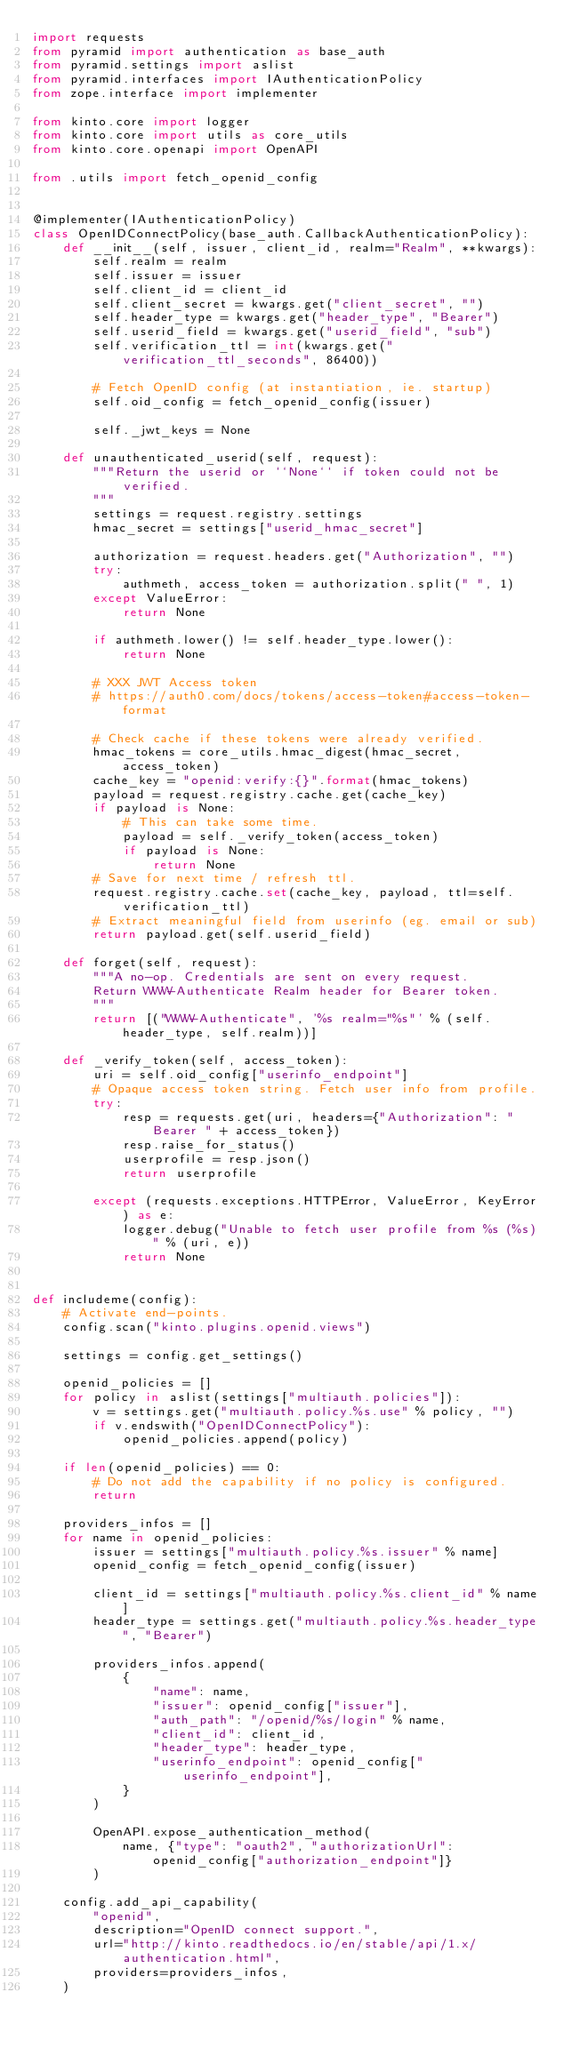Convert code to text. <code><loc_0><loc_0><loc_500><loc_500><_Python_>import requests
from pyramid import authentication as base_auth
from pyramid.settings import aslist
from pyramid.interfaces import IAuthenticationPolicy
from zope.interface import implementer

from kinto.core import logger
from kinto.core import utils as core_utils
from kinto.core.openapi import OpenAPI

from .utils import fetch_openid_config


@implementer(IAuthenticationPolicy)
class OpenIDConnectPolicy(base_auth.CallbackAuthenticationPolicy):
    def __init__(self, issuer, client_id, realm="Realm", **kwargs):
        self.realm = realm
        self.issuer = issuer
        self.client_id = client_id
        self.client_secret = kwargs.get("client_secret", "")
        self.header_type = kwargs.get("header_type", "Bearer")
        self.userid_field = kwargs.get("userid_field", "sub")
        self.verification_ttl = int(kwargs.get("verification_ttl_seconds", 86400))

        # Fetch OpenID config (at instantiation, ie. startup)
        self.oid_config = fetch_openid_config(issuer)

        self._jwt_keys = None

    def unauthenticated_userid(self, request):
        """Return the userid or ``None`` if token could not be verified.
        """
        settings = request.registry.settings
        hmac_secret = settings["userid_hmac_secret"]

        authorization = request.headers.get("Authorization", "")
        try:
            authmeth, access_token = authorization.split(" ", 1)
        except ValueError:
            return None

        if authmeth.lower() != self.header_type.lower():
            return None

        # XXX JWT Access token
        # https://auth0.com/docs/tokens/access-token#access-token-format

        # Check cache if these tokens were already verified.
        hmac_tokens = core_utils.hmac_digest(hmac_secret, access_token)
        cache_key = "openid:verify:{}".format(hmac_tokens)
        payload = request.registry.cache.get(cache_key)
        if payload is None:
            # This can take some time.
            payload = self._verify_token(access_token)
            if payload is None:
                return None
        # Save for next time / refresh ttl.
        request.registry.cache.set(cache_key, payload, ttl=self.verification_ttl)
        # Extract meaningful field from userinfo (eg. email or sub)
        return payload.get(self.userid_field)

    def forget(self, request):
        """A no-op. Credentials are sent on every request.
        Return WWW-Authenticate Realm header for Bearer token.
        """
        return [("WWW-Authenticate", '%s realm="%s"' % (self.header_type, self.realm))]

    def _verify_token(self, access_token):
        uri = self.oid_config["userinfo_endpoint"]
        # Opaque access token string. Fetch user info from profile.
        try:
            resp = requests.get(uri, headers={"Authorization": "Bearer " + access_token})
            resp.raise_for_status()
            userprofile = resp.json()
            return userprofile

        except (requests.exceptions.HTTPError, ValueError, KeyError) as e:
            logger.debug("Unable to fetch user profile from %s (%s)" % (uri, e))
            return None


def includeme(config):
    # Activate end-points.
    config.scan("kinto.plugins.openid.views")

    settings = config.get_settings()

    openid_policies = []
    for policy in aslist(settings["multiauth.policies"]):
        v = settings.get("multiauth.policy.%s.use" % policy, "")
        if v.endswith("OpenIDConnectPolicy"):
            openid_policies.append(policy)

    if len(openid_policies) == 0:
        # Do not add the capability if no policy is configured.
        return

    providers_infos = []
    for name in openid_policies:
        issuer = settings["multiauth.policy.%s.issuer" % name]
        openid_config = fetch_openid_config(issuer)

        client_id = settings["multiauth.policy.%s.client_id" % name]
        header_type = settings.get("multiauth.policy.%s.header_type", "Bearer")

        providers_infos.append(
            {
                "name": name,
                "issuer": openid_config["issuer"],
                "auth_path": "/openid/%s/login" % name,
                "client_id": client_id,
                "header_type": header_type,
                "userinfo_endpoint": openid_config["userinfo_endpoint"],
            }
        )

        OpenAPI.expose_authentication_method(
            name, {"type": "oauth2", "authorizationUrl": openid_config["authorization_endpoint"]}
        )

    config.add_api_capability(
        "openid",
        description="OpenID connect support.",
        url="http://kinto.readthedocs.io/en/stable/api/1.x/authentication.html",
        providers=providers_infos,
    )
</code> 